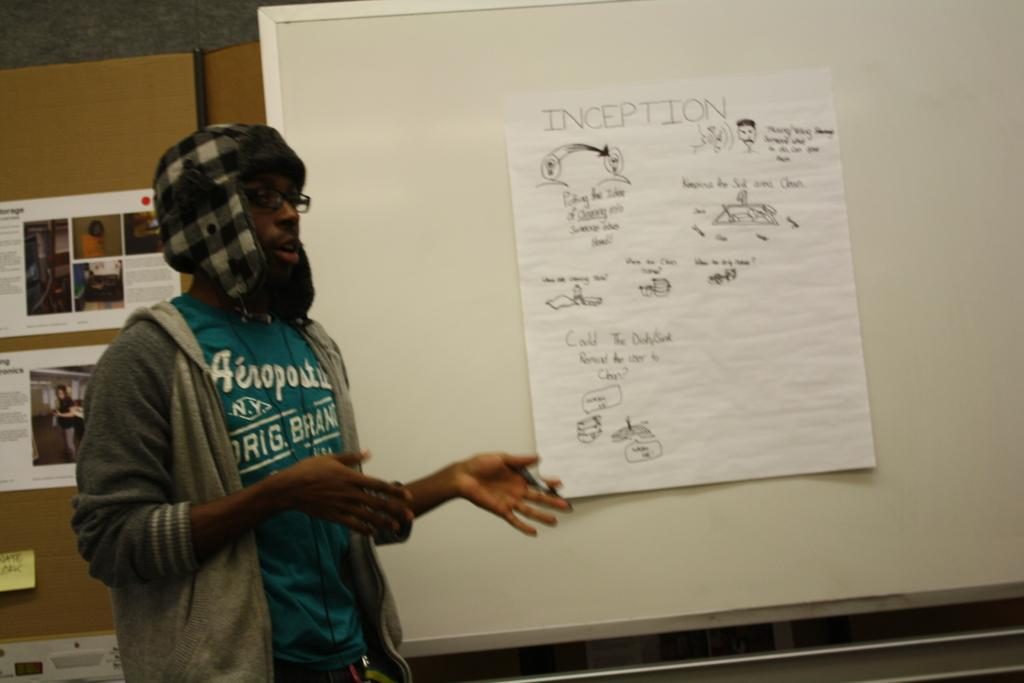<image>
Give a short and clear explanation of the subsequent image. A man stands near a piece of paper that's taped to the board that says "inception"" on it. 